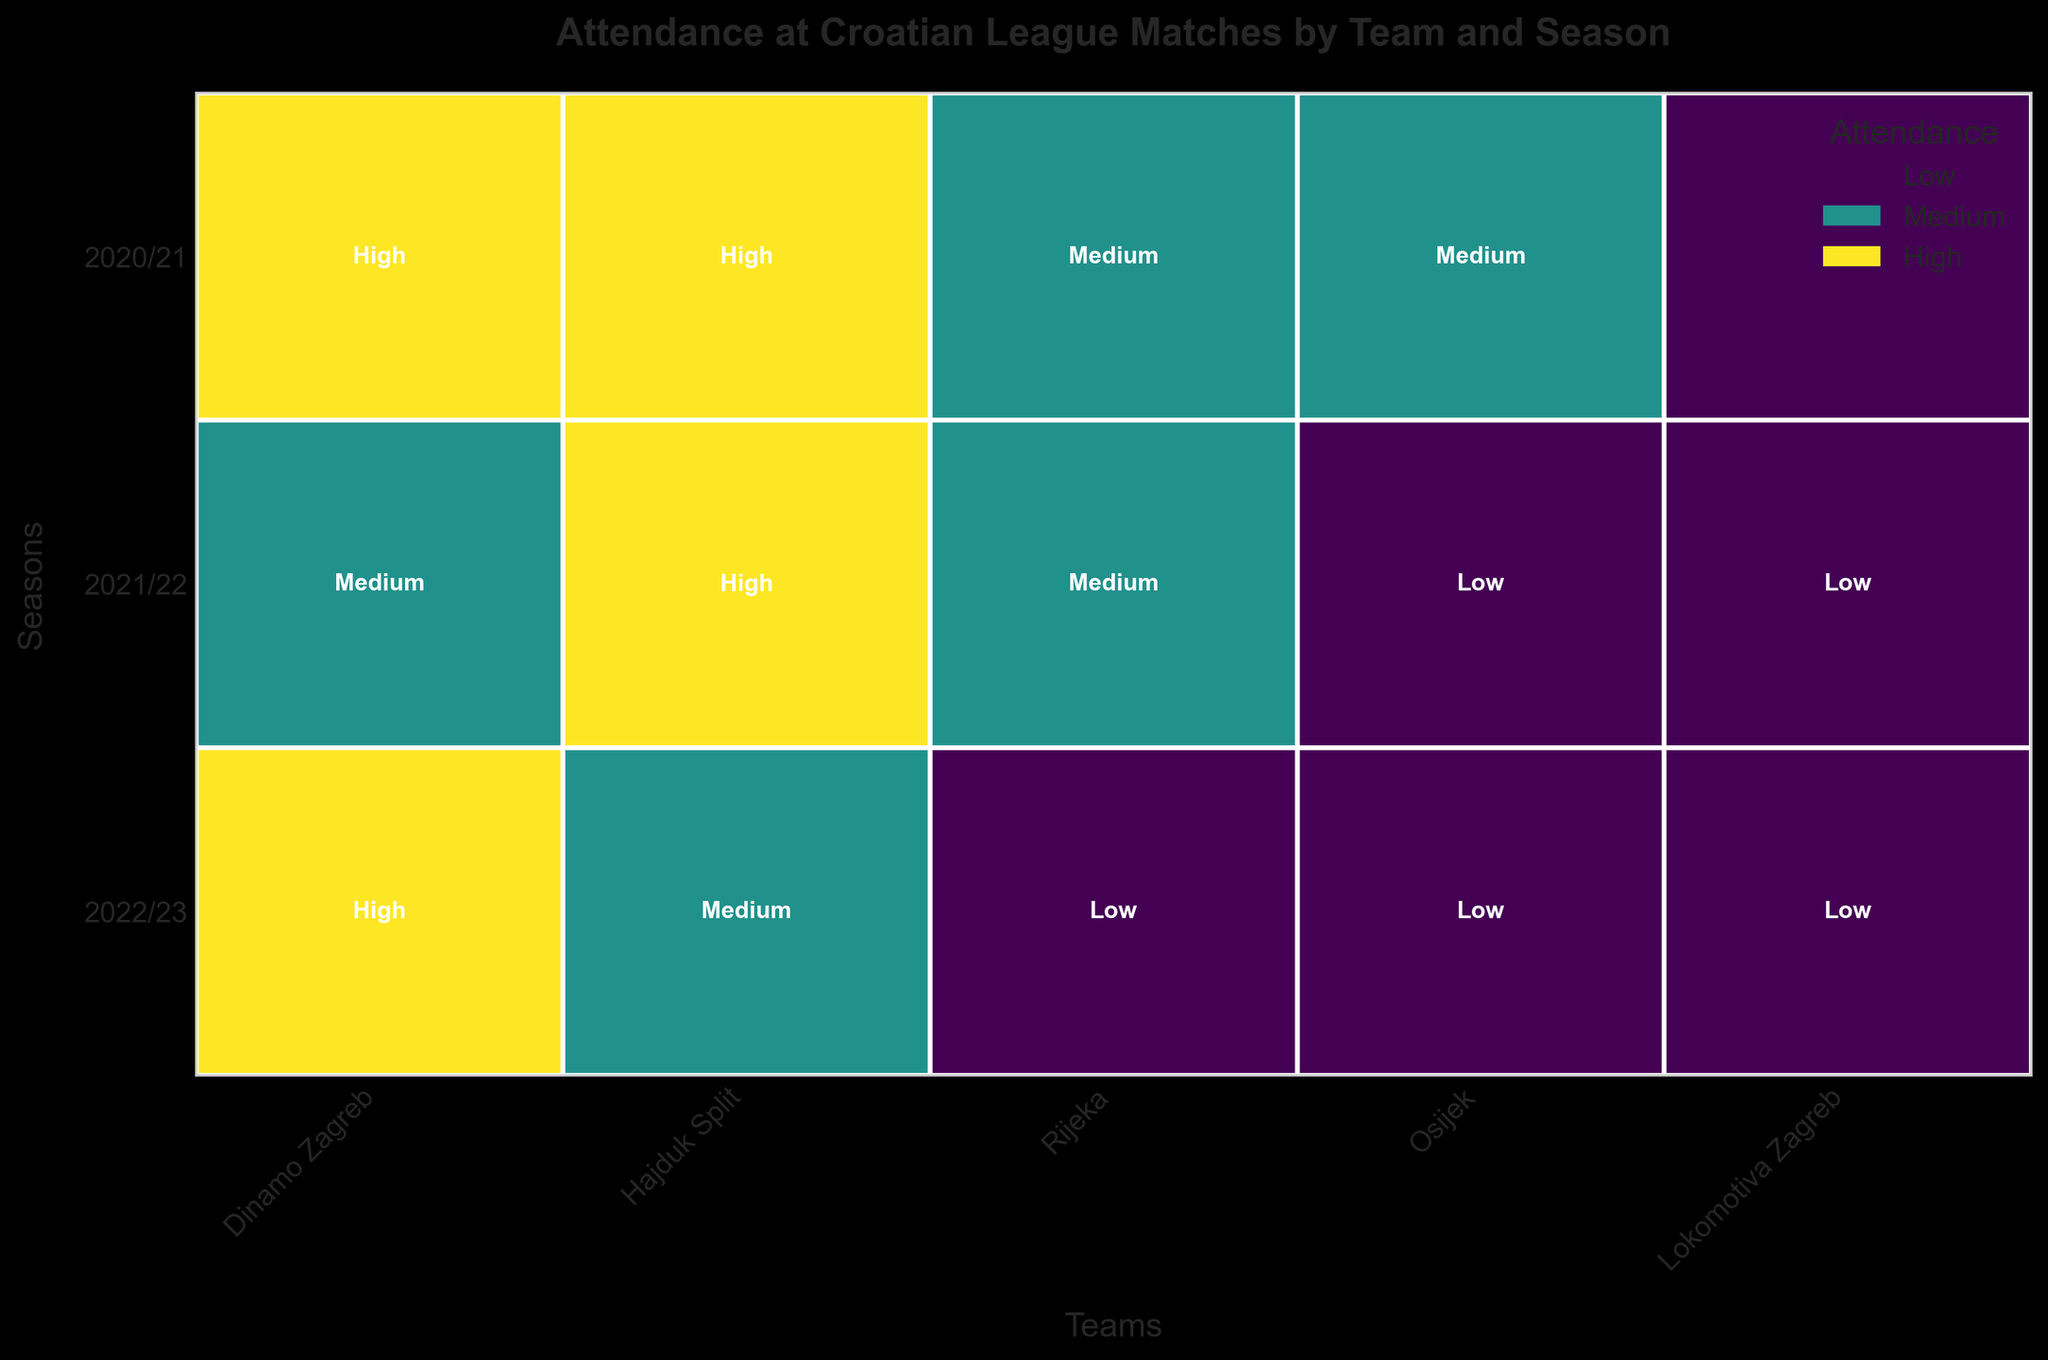Which team has the highest attendance in the 2020/21 season? First, identify the 2020/21 row in the mosaic plot, then find the boxes under that row. The 'High' label is visible within Dinamo Zagreb's box.
Answer: Dinamo Zagreb Which seasons have 'High' attendance for Hajduk Split? Look at the blocks corresponding to Hajduk Split. You’ll see that the 'High' attendance label appears for the 2021/22 and 2022/23 seasons.
Answer: 2021/22 and 2022/23 How many teams had 'Low' attendance in the 2021/22 season? Check the 2021/22 row. Locate the blocks labeled 'Low.' The labels are visible for Lokomotiva Zagreb and Osijek.
Answer: Two teams Which team has 'Low' attendance across all three seasons? Scan each team's attendance by season. Lokomotiva Zagreb shows 'Low' attendance for 2020/21, 2021/22, and 2022/23.
Answer: Lokomotiva Zagreb Do more teams have 'High' or 'Low' attendance in the 2022/23 season? Count the teams with 'High' and 'Low' attendance labels in the 2022/23 row. 'High' is visible under Dinamo Zagreb and Hajduk Split (2 teams), while 'Low' is only under Lokomotiva Zagreb (1 team).
Answer: High attendance Which team’s attendance improved from 'Low' to 'Medium' over the seasons? Observe each team’s changing attendance levels. Osijek’s attendance evolved from 'Low' (2020/21 and 2021/22) to 'Medium' (2022/23).
Answer: Osijek Did Rijeka ever reach 'High' attendance during these seasons? Look at Rijeka’s boxes across all seasons. None of the boxes show 'High' attendance.
Answer: No Which team shows a consistent 'Medium' attendance for the last two seasons? Look at the 'Medium' labeled blocks. Rijeka shows 'Medium' attendance for both 2021/22 and 2022/23 seasons.
Answer: Rijeka 